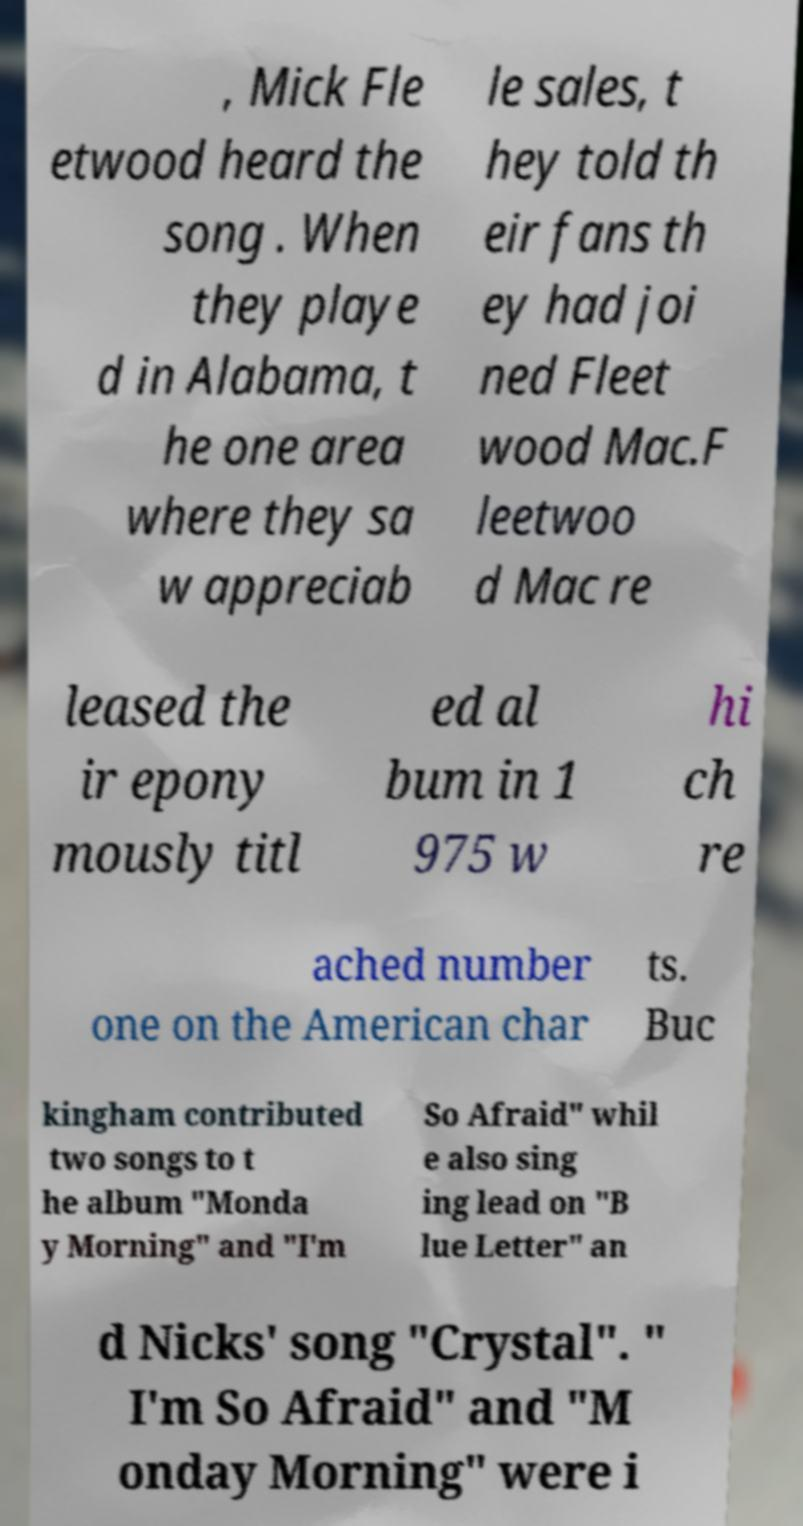Please read and relay the text visible in this image. What does it say? , Mick Fle etwood heard the song . When they playe d in Alabama, t he one area where they sa w appreciab le sales, t hey told th eir fans th ey had joi ned Fleet wood Mac.F leetwoo d Mac re leased the ir epony mously titl ed al bum in 1 975 w hi ch re ached number one on the American char ts. Buc kingham contributed two songs to t he album "Monda y Morning" and "I'm So Afraid" whil e also sing ing lead on "B lue Letter" an d Nicks' song "Crystal". " I'm So Afraid" and "M onday Morning" were i 